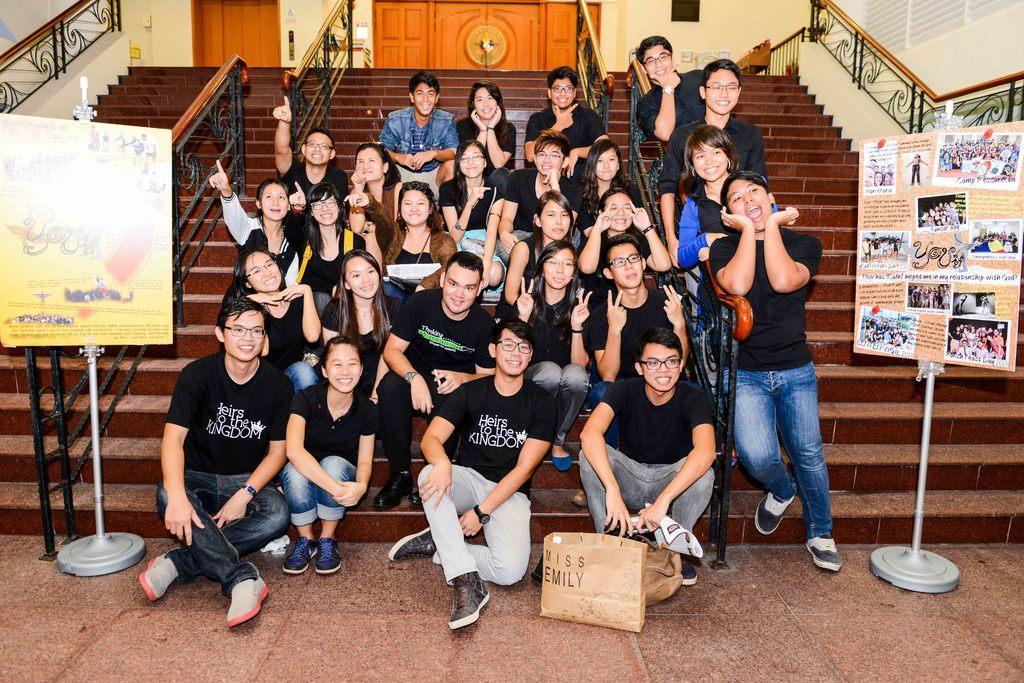How would you summarize this image in a sentence or two? In this image, we can see some people sitting on the stairs, there are some brown color stairs, we can see two yellow color doors, at the right side there is a poster on a board and there are some people standing. 